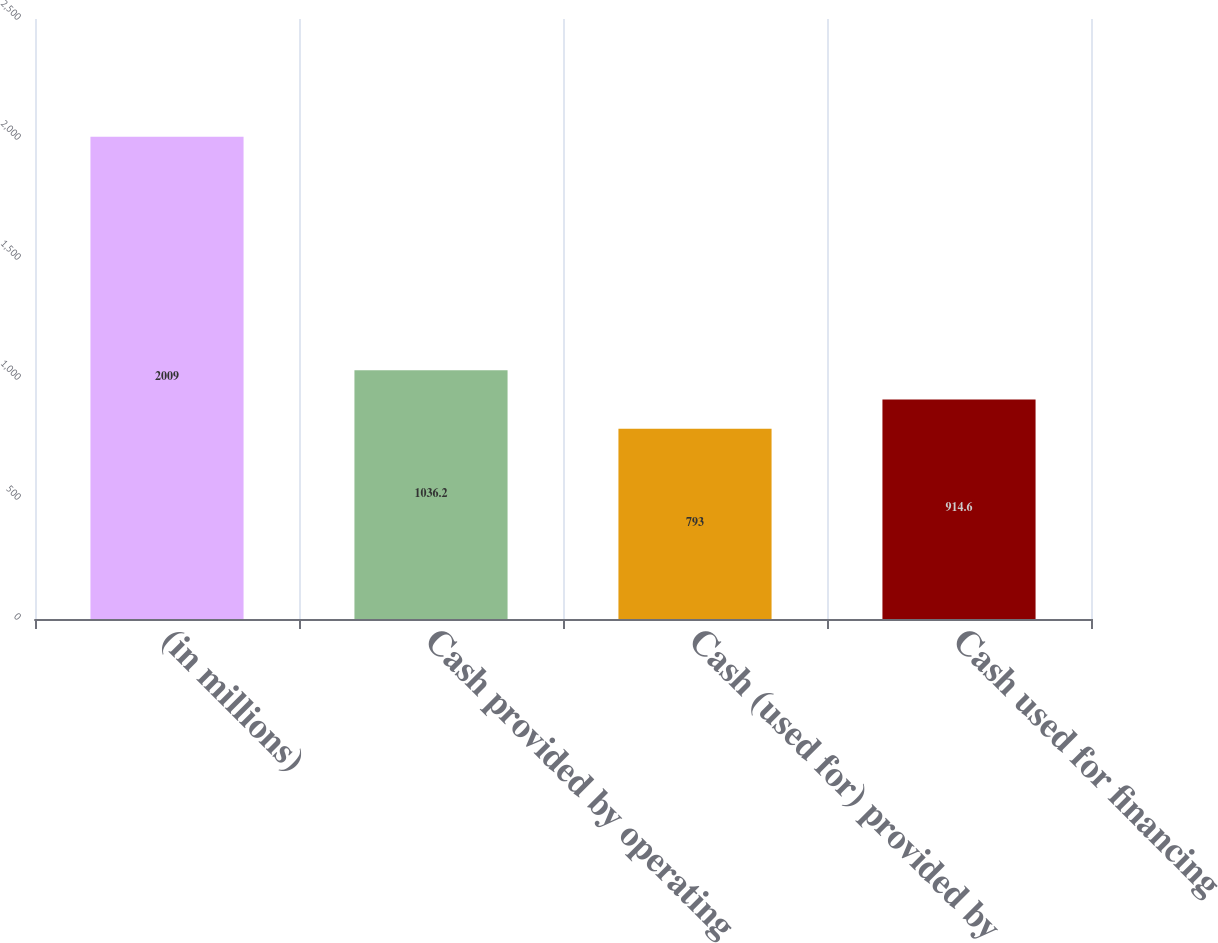Convert chart to OTSL. <chart><loc_0><loc_0><loc_500><loc_500><bar_chart><fcel>(in millions)<fcel>Cash provided by operating<fcel>Cash (used for) provided by<fcel>Cash used for financing<nl><fcel>2009<fcel>1036.2<fcel>793<fcel>914.6<nl></chart> 